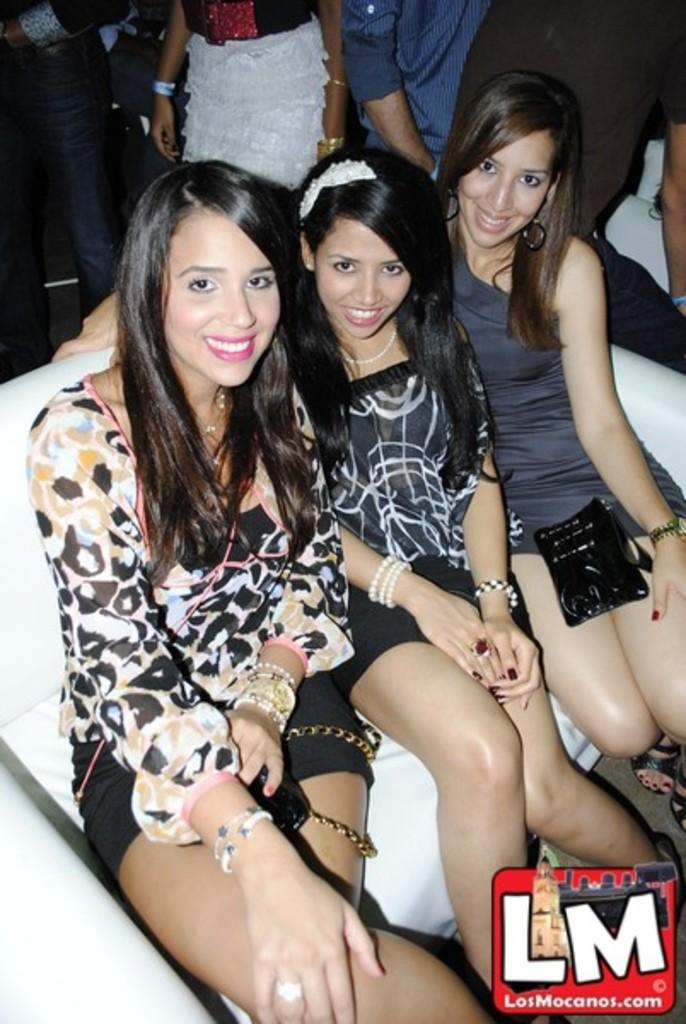How many women are in the image? There are three women in the image. What are the women doing in the image? The women are sitting on a sofa and smiling. Can you describe the people in the background of the image? There are people in the background of the image, but their specific actions or features are not mentioned in the provided facts. What is located at the bottom of the image? There is a logo at the bottom of the image. What type of bone can be seen in the hands of the women in the image? There is no bone present in the image; the women are sitting on a sofa and smiling. 